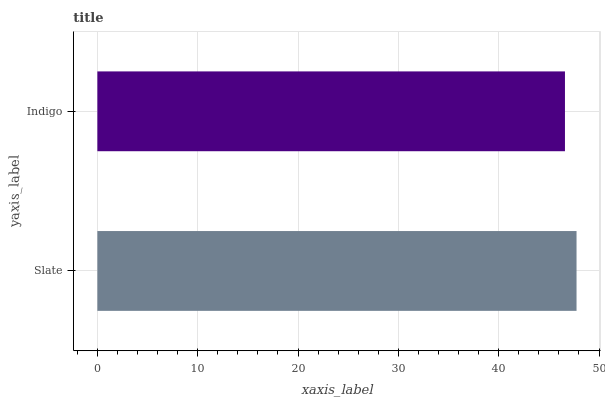Is Indigo the minimum?
Answer yes or no. Yes. Is Slate the maximum?
Answer yes or no. Yes. Is Indigo the maximum?
Answer yes or no. No. Is Slate greater than Indigo?
Answer yes or no. Yes. Is Indigo less than Slate?
Answer yes or no. Yes. Is Indigo greater than Slate?
Answer yes or no. No. Is Slate less than Indigo?
Answer yes or no. No. Is Slate the high median?
Answer yes or no. Yes. Is Indigo the low median?
Answer yes or no. Yes. Is Indigo the high median?
Answer yes or no. No. Is Slate the low median?
Answer yes or no. No. 